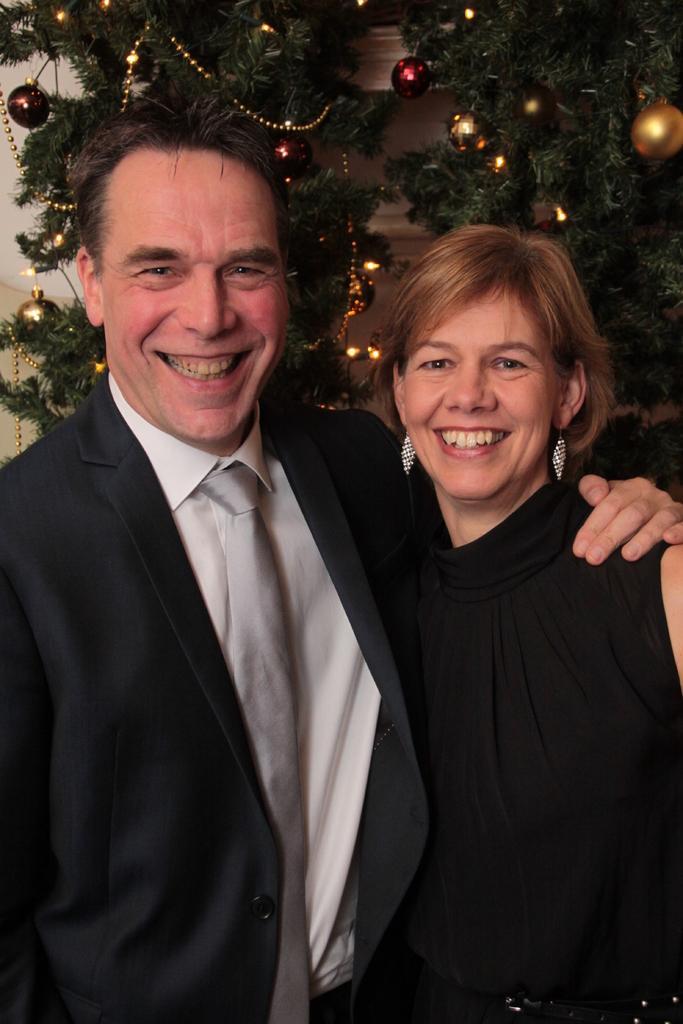Could you give a brief overview of what you see in this image? In this image there is a man and woman standing together and smiling, behind them there is a christmas tree in front of a wall. 